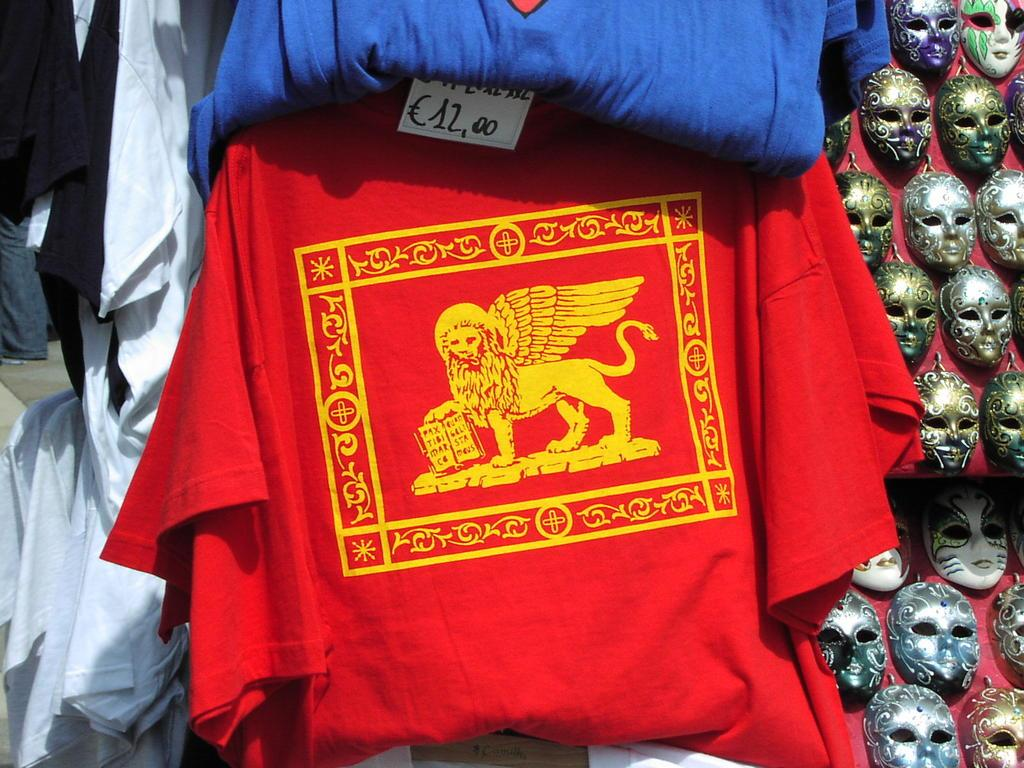What is located in the center of the image? There are clothes in the center of the image. What can be seen on the right side of the image? There are masks on the right side of the image. What is the owner of the masks doing in the image? There is no indication of an owner of the masks in the image. What position are the masks in the image? The masks are on the right side of the image, but their position relative to each other or the clothes is not specified. What type of game or activity is being played in the image? There is no game or activity being played in the image; it only features clothes and masks. 